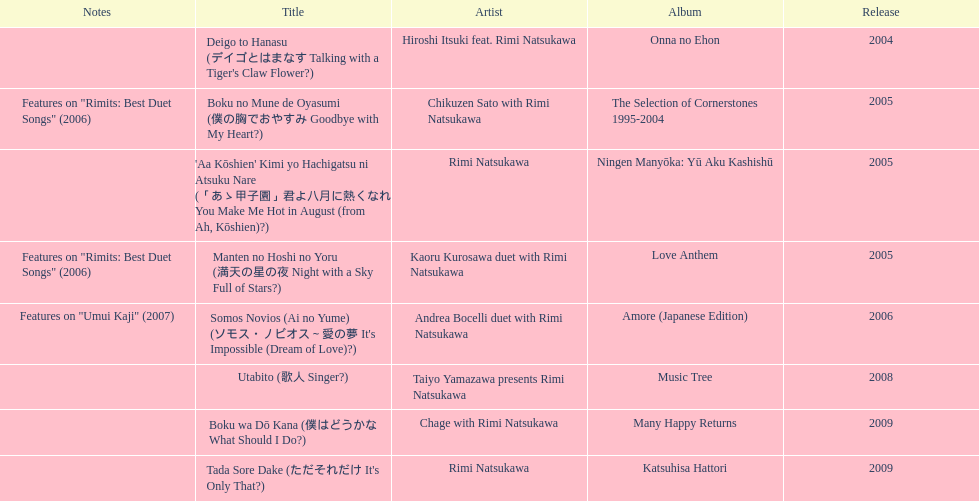Which year had the most titles released? 2005. Can you give me this table as a dict? {'header': ['Notes', 'Title', 'Artist', 'Album', 'Release'], 'rows': [['', "Deigo to Hanasu (デイゴとはまなす Talking with a Tiger's Claw Flower?)", 'Hiroshi Itsuki feat. Rimi Natsukawa', 'Onna no Ehon', '2004'], ['Features on "Rimits: Best Duet Songs" (2006)', 'Boku no Mune de Oyasumi (僕の胸でおやすみ Goodbye with My Heart?)', 'Chikuzen Sato with Rimi Natsukawa', 'The Selection of Cornerstones 1995-2004', '2005'], ['', "'Aa Kōshien' Kimi yo Hachigatsu ni Atsuku Nare (「あゝ甲子園」君よ八月に熱くなれ You Make Me Hot in August (from Ah, Kōshien)?)", 'Rimi Natsukawa', 'Ningen Manyōka: Yū Aku Kashishū', '2005'], ['Features on "Rimits: Best Duet Songs" (2006)', 'Manten no Hoshi no Yoru (満天の星の夜 Night with a Sky Full of Stars?)', 'Kaoru Kurosawa duet with Rimi Natsukawa', 'Love Anthem', '2005'], ['Features on "Umui Kaji" (2007)', "Somos Novios (Ai no Yume) (ソモス・ノビオス～愛の夢 It's Impossible (Dream of Love)?)", 'Andrea Bocelli duet with Rimi Natsukawa', 'Amore (Japanese Edition)', '2006'], ['', 'Utabito (歌人 Singer?)', 'Taiyo Yamazawa presents Rimi Natsukawa', 'Music Tree', '2008'], ['', 'Boku wa Dō Kana (僕はどうかな What Should I Do?)', 'Chage with Rimi Natsukawa', 'Many Happy Returns', '2009'], ['', "Tada Sore Dake (ただそれだけ It's Only That?)", 'Rimi Natsukawa', 'Katsuhisa Hattori', '2009']]} 